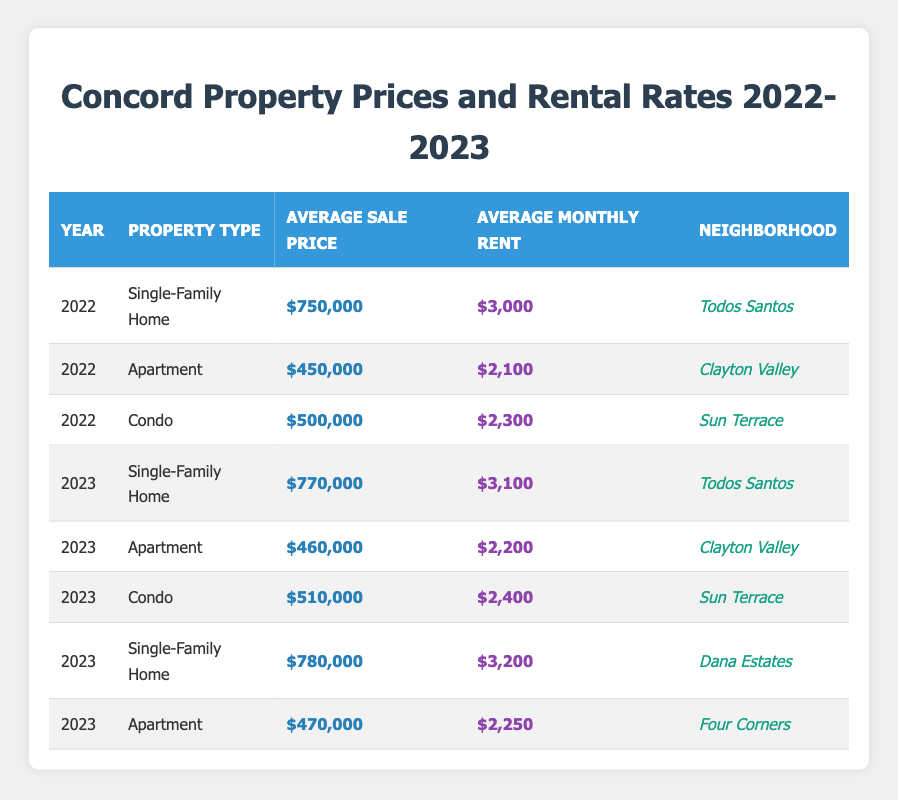What was the average sale price of a condo in Concord in 2022? Referring to the table for 2022, the average sale price of a condo is listed as $500,000.
Answer: $500,000 What is the average monthly rent for single-family homes in Todos Santos in 2023? Looking at the table for 2023, the average monthly rent for single-family homes in Todos Santos is $3,100.
Answer: $3,100 How much did the average sale price of apartments increase from 2022 to 2023? The average sale price of apartments in 2022 is $450,000, and in 2023 it is $460,000. The difference is $460,000 - $450,000 = $10,000.
Answer: $10,000 Is the average monthly rent for a condo higher in 2023 compared to 2022? In 2022, the average monthly rent for a condo is $2,300, and in 2023, it is $2,400. Since $2,400 is greater than $2,300, the statement is true.
Answer: Yes Which property type in Dana Estates had the highest average sale price in 2023? The table shows that in Dana Estates, the average sale price for a single-family home in 2023 is $780,000, which is higher compared to other property types in that year.
Answer: Single-Family Home How much did the average monthly rent for apartments increase from 2022 to 2023? The average monthly rent for apartments in 2022 is $2,100, and in 2023 it is $2,200. The increase is calculated as $2,200 - $2,100 = $100.
Answer: $100 Are there any condos listed for sale at a higher price in 2023 compared to any single-family homes in the same año? The average sale price of condos in 2023 is $510,000, while the average sale prices of single-family homes in 2023 are $770,000 and $780,000. Since both single-family homes are priced higher, the statement is false.
Answer: No What is the difference in average monthly rent between the two neighborhoods for apartments in 2023? In 2023, the average monthly rent for apartments in Clayton Valley is $2,200, while in Four Corners it is $2,250. The difference is $2,250 - $2,200 = $50.
Answer: $50 